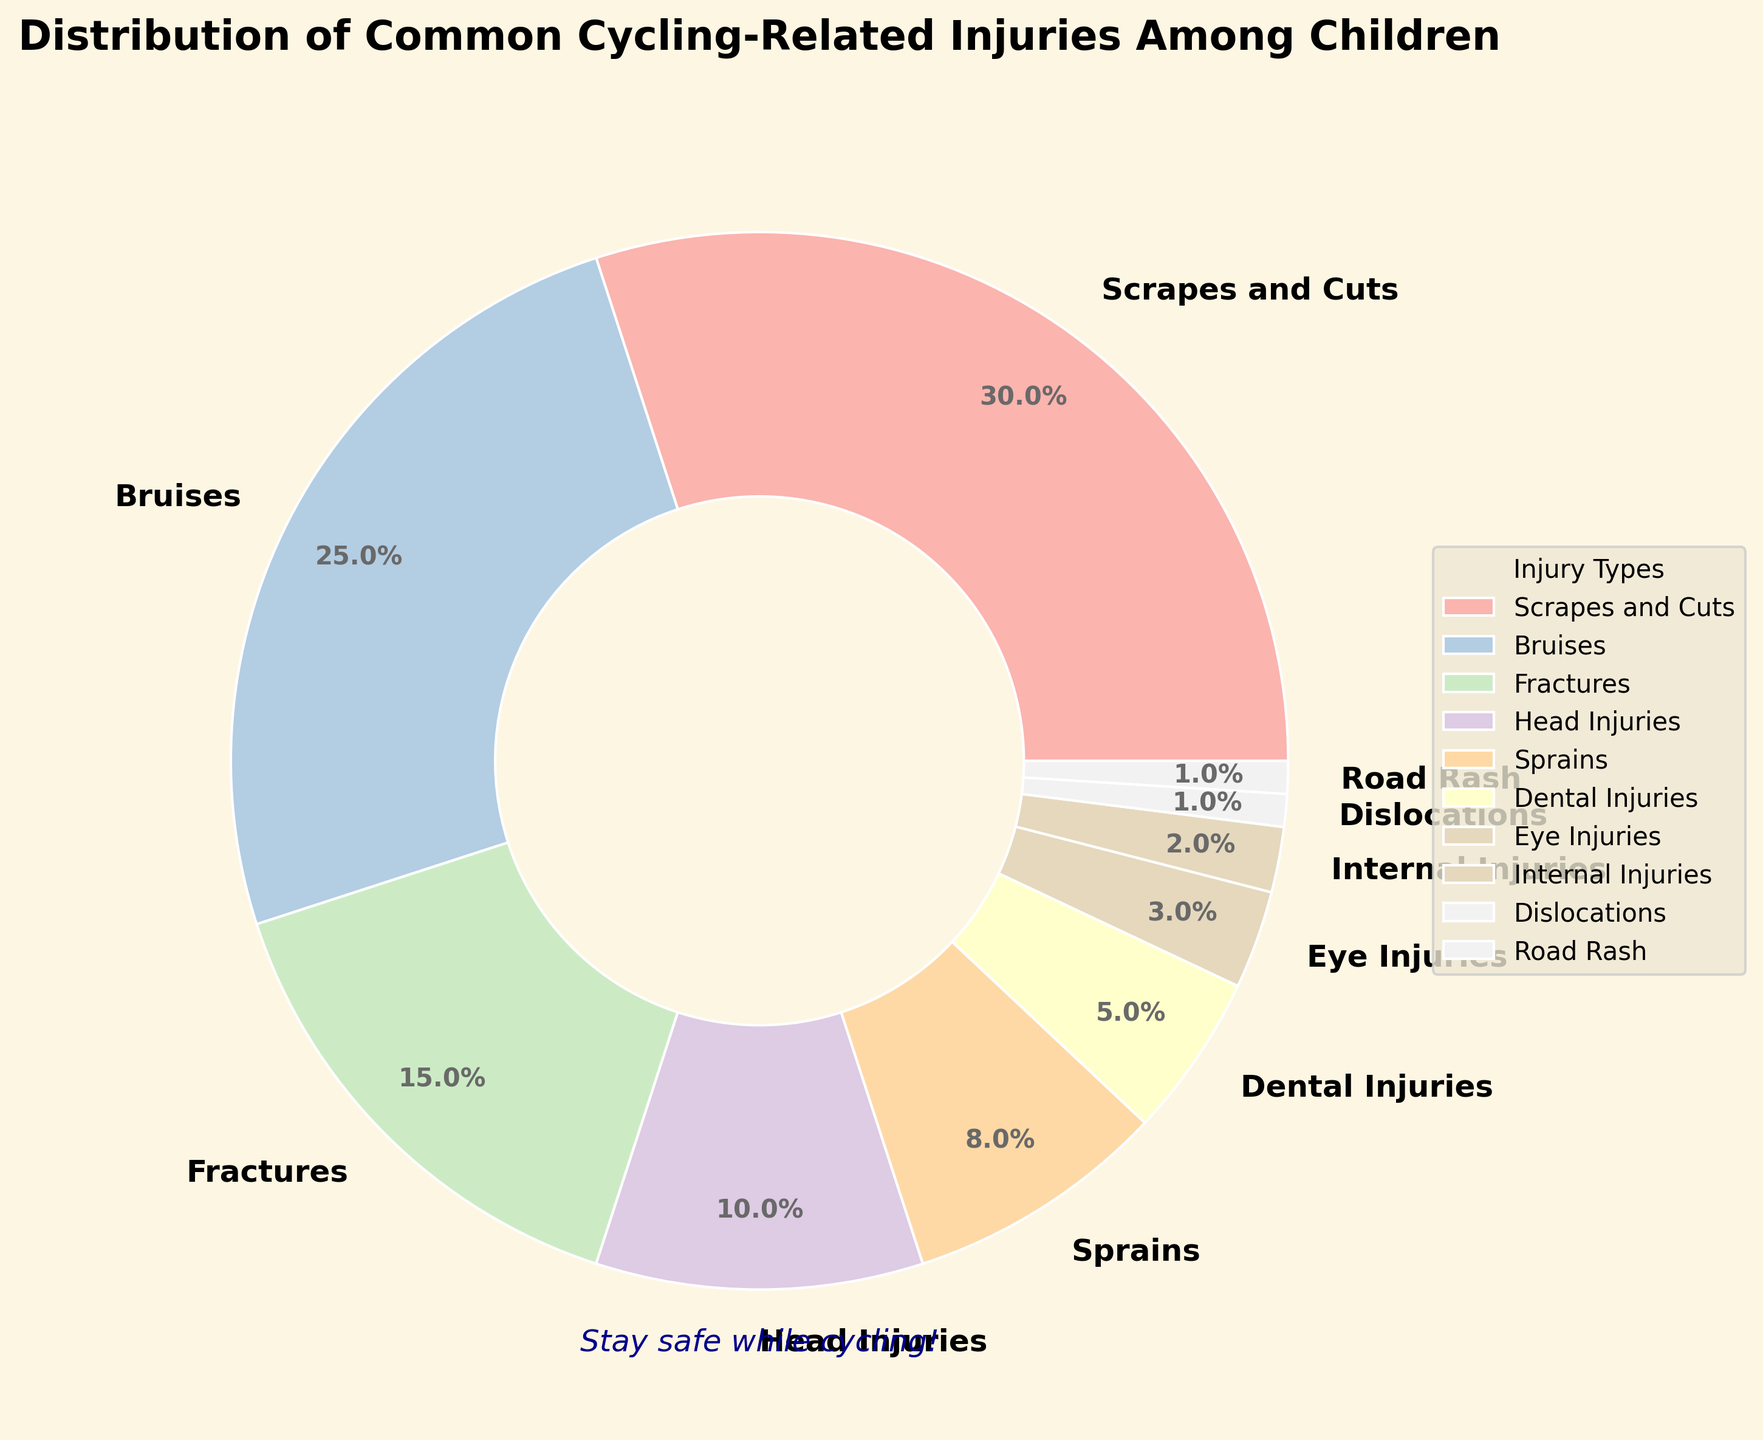Which type of injury is most common among children cycling-related injuries? The pie chart shows that "Scrapes and Cuts" has the largest wedge, indicating it has the highest percentage.
Answer: Scrapes and Cuts What is the combined percentage of Bruises and Fractures in cycling-related injuries among children? The chart shows "Bruises" have 25% and "Fractures" have 15%. Adding these percentages together gives: 25% + 15% = 40%.
Answer: 40% Which injury types together make up less than 10% of the total cycling-related injuries? The chart indicates "Dental Injuries" are 5%, "Eye Injuries" are 3%, "Internal Injuries" are 2%, "Dislocations" are 1%, "Road Rash" are 1%. Summing them up: 5% + 3% + 2% + 1% + 1% = 12%. Only "Eye Injuries", "Internal Injuries", "Dislocations", and "Road Rash" together are under 10%.
Answer: Eye Injuries, Internal Injuries, Dislocations, Road Rash How does the percentage of Head Injuries compare to that of Sprains? The chart shows "Head Injuries" are 10% and "Sprains" are 8%. So, Head Injuries have a higher percentage.
Answer: Head Injuries have a higher percentage What is the percentage difference between Scrapes and Cuts and Bruises? The chart lists "Scrapes and Cuts" as 30% and "Bruises" as 25%. The difference is calculated as 30% - 25% = 5%.
Answer: 5% Which injuries have a lower percentage than Fractures? From the chart, "Fractures" are 15%. Therefore, "Head Injuries" (10%), "Sprains" (8%), "Dental Injuries" (5%), "Eye Injuries" (3%), "Internal Injuries" (2%), "Dislocations" (1%), "Road Rash" (1%) all have lower percentages.
Answer: Head Injuries, Sprains, Dental Injuries, Eye Injuries, Internal Injuries, Dislocations, Road Rash What is the average percentage of injuries labeled from "Sprains" to "Dislocations"? Summing the percentages: "Sprains" (8%) + "Dental Injuries" (5%) + "Eye Injuries" (3%) + "Internal Injuries" (2%) + "Dislocations" (1%) = 19%. There are 5 injury types, so 19% / 5 = 3.8%.
Answer: 3.8% Which injuries combined account for half of all cycling-related injuries among children? Checking the cumulative percentage: "Scrapes and Cuts" (30%) and "Bruises" (25%) together make 30% + 25% = 55%, which exceeds 50%, so separately Scrapes and Cuts or Bruises don't meet this, thus combined they do.
Answer: Scrapes and Cuts, Bruises 